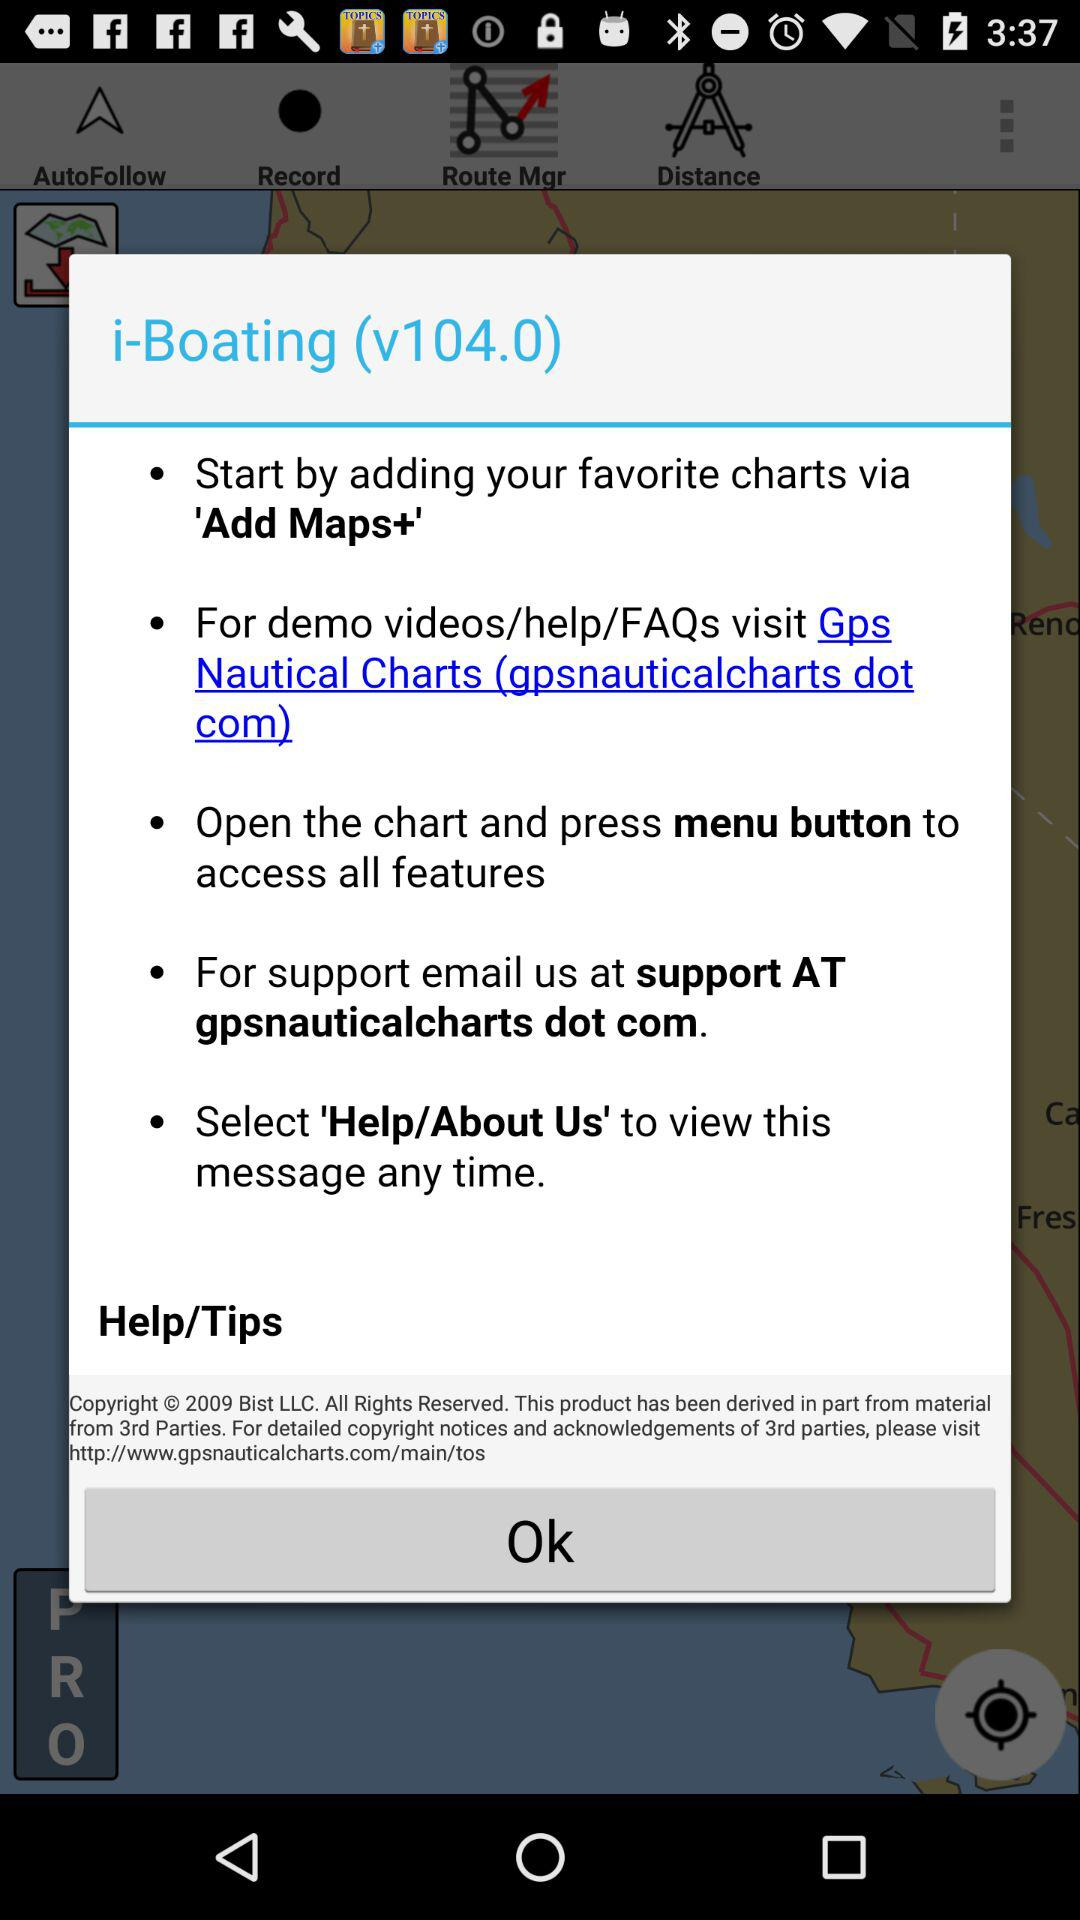What is the version of the application? The version of the application is v104.0. 